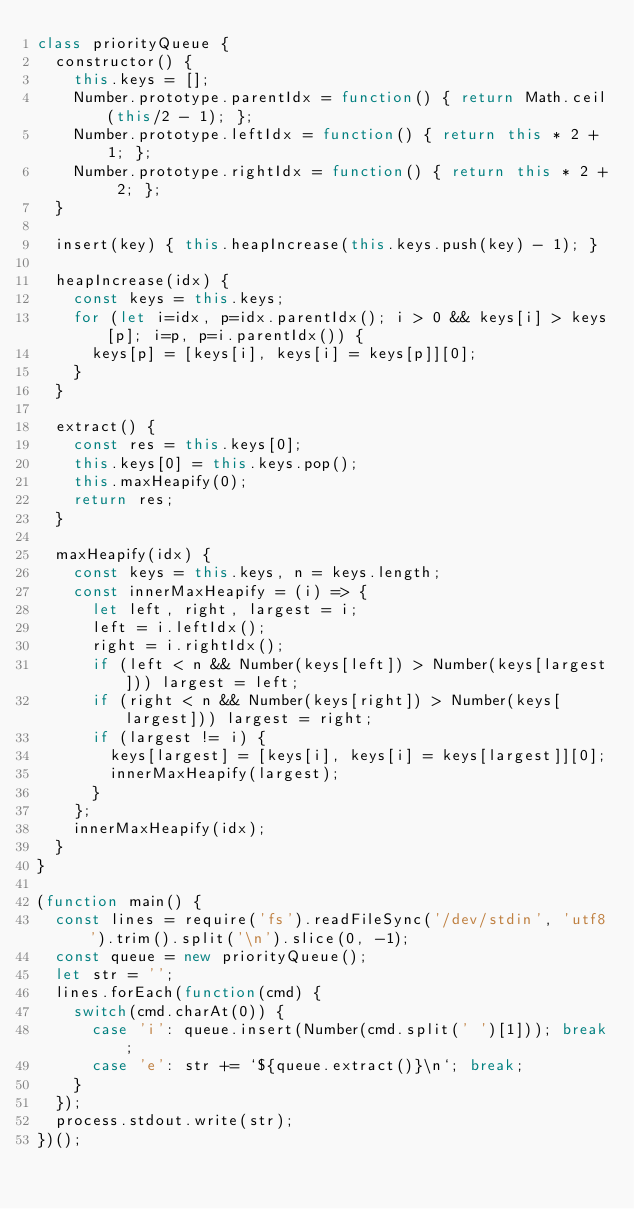<code> <loc_0><loc_0><loc_500><loc_500><_JavaScript_>class priorityQueue {
  constructor() {
    this.keys = [];
    Number.prototype.parentIdx = function() { return Math.ceil(this/2 - 1); };
    Number.prototype.leftIdx = function() { return this * 2 + 1; };
    Number.prototype.rightIdx = function() { return this * 2 + 2; };
  }

  insert(key) { this.heapIncrease(this.keys.push(key) - 1); }

  heapIncrease(idx) {
    const keys = this.keys;
    for (let i=idx, p=idx.parentIdx(); i > 0 && keys[i] > keys[p]; i=p, p=i.parentIdx()) {
      keys[p] = [keys[i], keys[i] = keys[p]][0];
    }
  }

  extract() {
    const res = this.keys[0];
    this.keys[0] = this.keys.pop();
    this.maxHeapify(0);
    return res;
  }

  maxHeapify(idx) {
    const keys = this.keys, n = keys.length;
    const innerMaxHeapify = (i) => {
      let left, right, largest = i;
      left = i.leftIdx();
      right = i.rightIdx();
      if (left < n && Number(keys[left]) > Number(keys[largest])) largest = left;
      if (right < n && Number(keys[right]) > Number(keys[largest])) largest = right;
      if (largest != i) {
        keys[largest] = [keys[i], keys[i] = keys[largest]][0];
        innerMaxHeapify(largest);
      }
    };
    innerMaxHeapify(idx);
  }
}

(function main() {
  const lines = require('fs').readFileSync('/dev/stdin', 'utf8').trim().split('\n').slice(0, -1);
  const queue = new priorityQueue();
  let str = '';
  lines.forEach(function(cmd) {
    switch(cmd.charAt(0)) {
      case 'i': queue.insert(Number(cmd.split(' ')[1])); break;
      case 'e': str += `${queue.extract()}\n`; break;
    }
  });
  process.stdout.write(str);
})();


</code> 